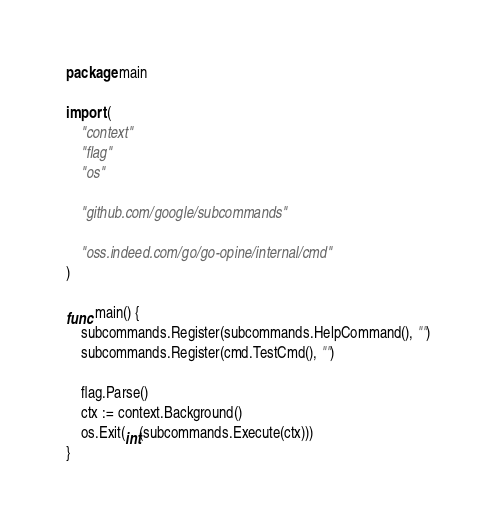<code> <loc_0><loc_0><loc_500><loc_500><_Go_>package main

import (
	"context"
	"flag"
	"os"

	"github.com/google/subcommands"

	"oss.indeed.com/go/go-opine/internal/cmd"
)

func main() {
	subcommands.Register(subcommands.HelpCommand(), "")
	subcommands.Register(cmd.TestCmd(), "")

	flag.Parse()
	ctx := context.Background()
	os.Exit(int(subcommands.Execute(ctx)))
}
</code> 